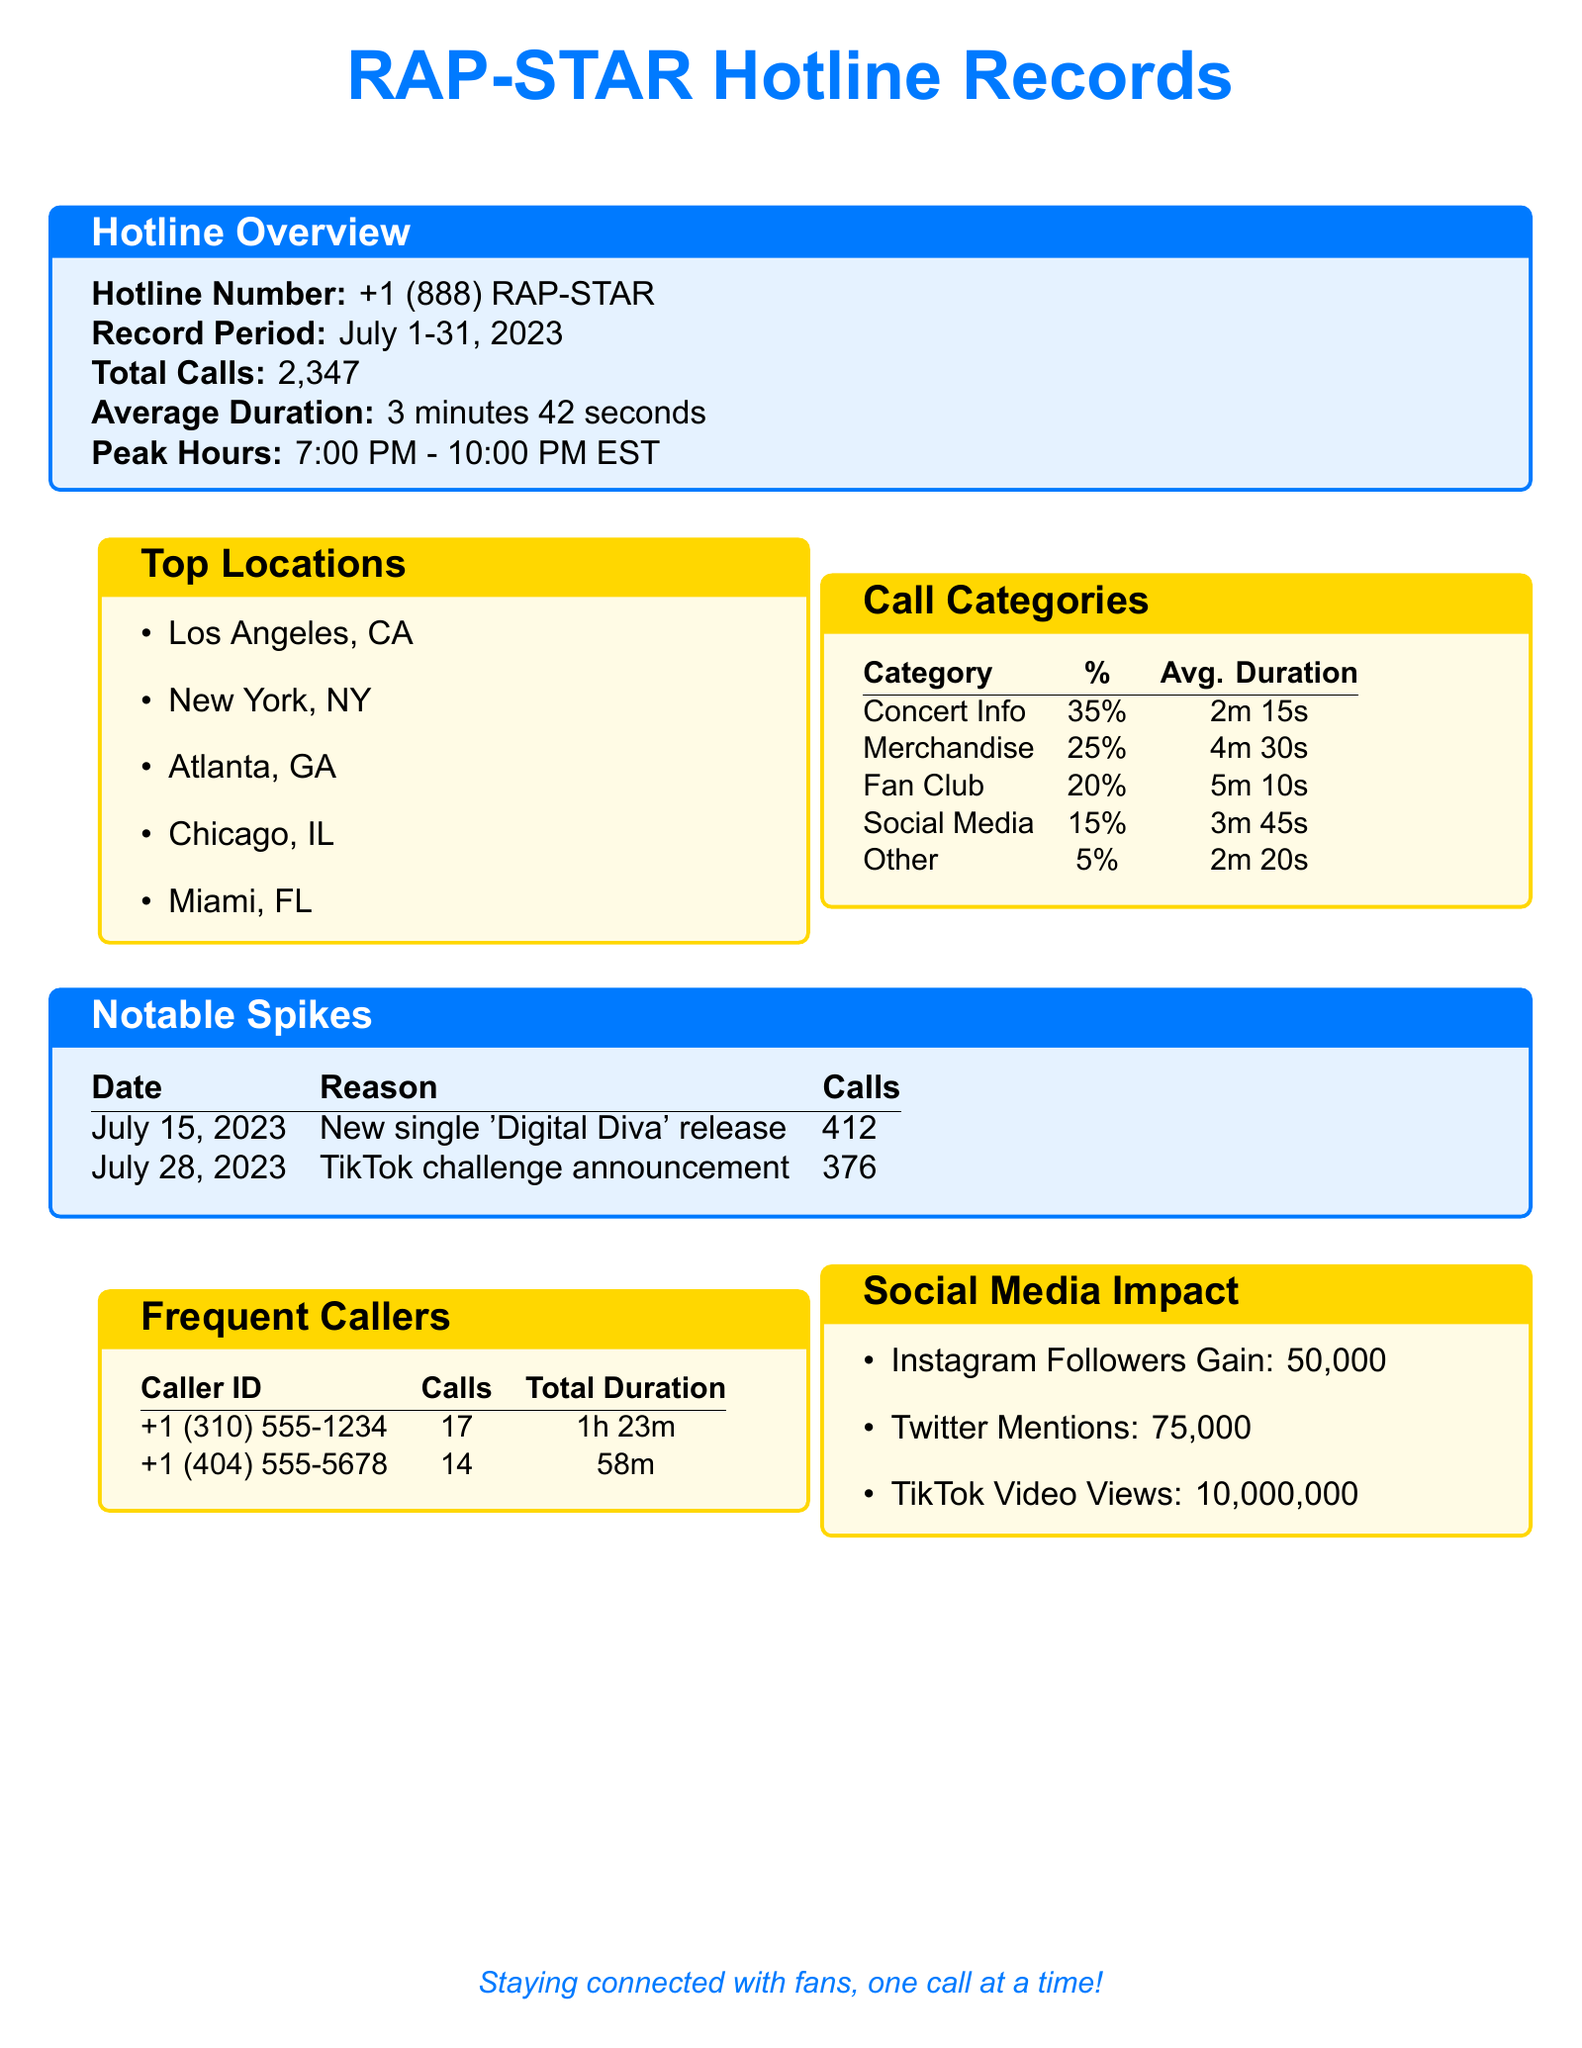What is the hotline number? The hotline number is provided in the document's overview section.
Answer: +1 (888) RAP-STAR What is the total number of calls received? The document states the total calls received during the record period.
Answer: 2,347 What was the average call duration? The average duration of the calls is mentioned in the hotline overview.
Answer: 3 minutes 42 seconds What percentage of calls were for concert information? The call categories table shows the percentage for concert information.
Answer: 35% On what date was there a notable spike in calls due to a new single release? The notable spikes section lists the exciting events with their corresponding dates.
Answer: July 15, 2023 Which city is listed as one of the top locations for hotline calls? The top locations section contains a list of cities.
Answer: Los Angeles, CA How many calls were made from the frequent caller with ID +1 (310) 555-1234? The frequent callers table provides the number of calls made from each caller ID.
Answer: 17 What was the reason for the call spike on July 28, 2023? The notable spikes section explains the reasons behind the call spikes.
Answer: TikTok challenge announcement How many Instagram followers were gained as part of the social media impact? The social media impact section reports on the follower increase.
Answer: 50,000 